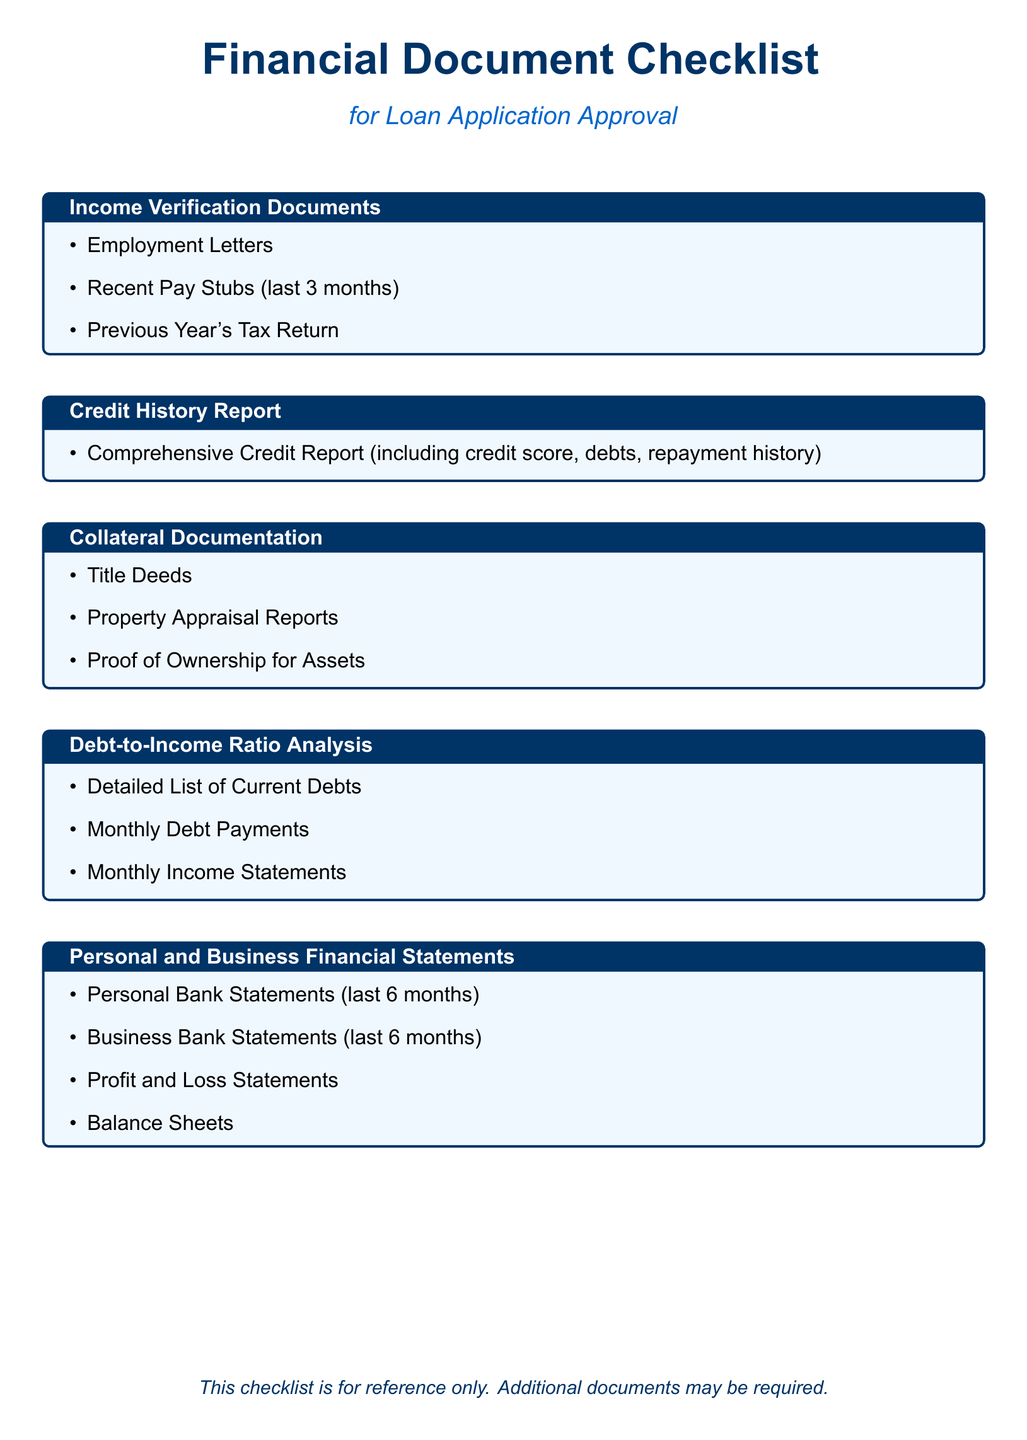What documents are required for income verification? The document specifies three types of income verification documents required, which are Employment Letters, Recent Pay Stubs, and Previous Year's Tax Return.
Answer: Employment Letters, Recent Pay Stubs, Previous Year's Tax Return What must be included in the credit history report? According to the checklist, the comprehensive credit report must include details about credit score, outstanding debts, and repayment history.
Answer: Credit score, outstanding debts, repayment history What type of documentation is needed for collateral? The document outlines three specific items needed for collateral documentation: Title Deeds, Property Appraisal Reports, and Proof of Ownership.
Answer: Title Deeds, Property Appraisal Reports, Proof of Ownership Which financial statements are required for personal finances? The checklist requires Personal Bank Statements, Business Bank Statements, Profit and Loss Statements, and Balance Sheets for financial documentation.
Answer: Personal Bank Statements, Business Bank Statements, Profit and Loss Statements, Balance Sheets What is assessed using the debt-to-income ratio analysis? The document lists specific financial information needed for analysis, including a detailed list of current debts, monthly debt payments, and monthly income.
Answer: Current debts, monthly debt payments, monthly income How many months of pay stubs are needed for income verification? The checklist specifies that recent pay stubs for the last three months are required for income verification.
Answer: Last 3 months What timeframe is specified for business bank statements? The document specifies that the latest business bank statements needed must cover the last six months.
Answer: Last 6 months What is required in the property appraisal reports? The checklist emphasizes the need for Property Appraisal Reports among collateral documentation, implying a valuation of the property is necessary.
Answer: Property Appraisal Reports 